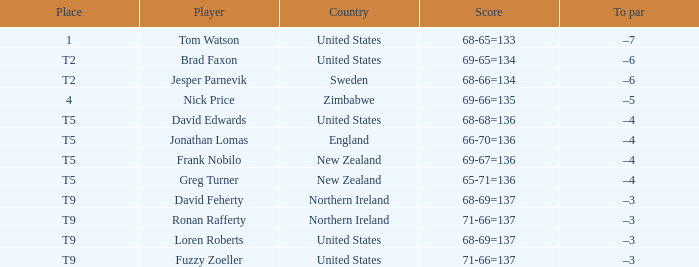With a score of 68-65=133 and United States as the country what is the To par? –7. 